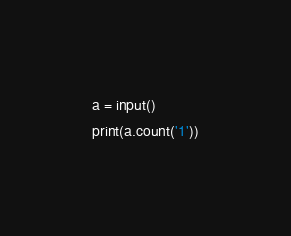Convert code to text. <code><loc_0><loc_0><loc_500><loc_500><_Python_>a = input()
print(a.count('1'))</code> 